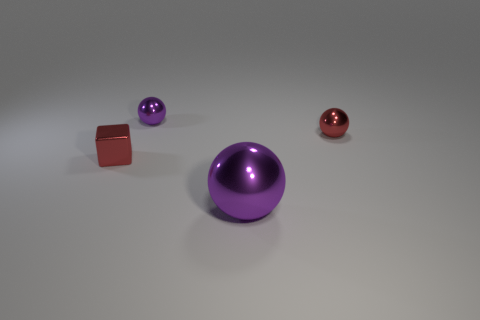Is there any other thing that has the same material as the red block?
Give a very brief answer. Yes. The red object that is in front of the tiny red thing on the right side of the sphere that is in front of the metal block is what shape?
Your answer should be compact. Cube. There is another metal sphere that is the same size as the red shiny sphere; what color is it?
Make the answer very short. Purple. How many cylinders are either small cyan matte objects or small red things?
Provide a succinct answer. 0. What number of tiny red things are there?
Make the answer very short. 2. Is the shape of the tiny purple metallic thing the same as the red metallic thing right of the tiny metallic block?
Your response must be concise. Yes. What size is the thing that is the same color as the shiny cube?
Ensure brevity in your answer.  Small. What number of objects are tiny green shiny cylinders or large spheres?
Your answer should be very brief. 1. What shape is the tiny red metallic object that is to the right of the metal block that is in front of the tiny purple thing?
Make the answer very short. Sphere. Is the shape of the purple object that is in front of the small red ball the same as  the small purple metallic object?
Your answer should be very brief. Yes. 